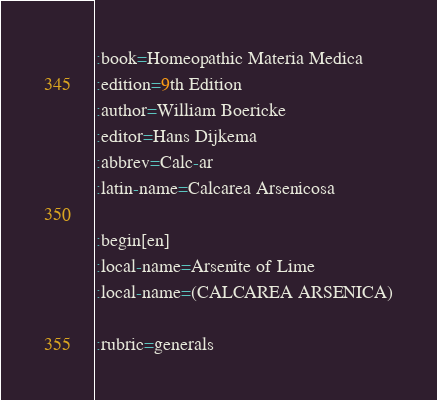Convert code to text. <code><loc_0><loc_0><loc_500><loc_500><_ObjectiveC_>:book=Homeopathic Materia Medica
:edition=9th Edition
:author=William Boericke
:editor=Hans Dijkema
:abbrev=Calc-ar
:latin-name=Calcarea Arsenicosa

:begin[en]
:local-name=Arsenite of Lime
:local-name=(CALCAREA ARSENICA)

:rubric=generals</code> 